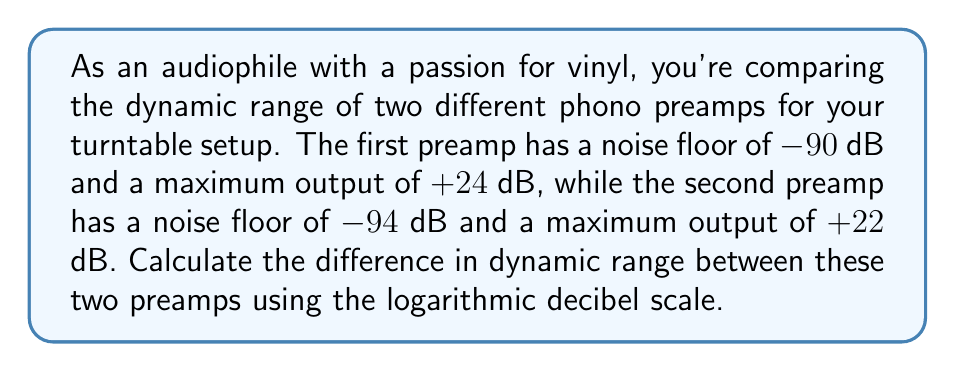Show me your answer to this math problem. To solve this problem, we'll follow these steps:

1. Calculate the dynamic range of each preamp:
   Dynamic range = Maximum output - Noise floor

2. For the first preamp:
   $DR_1 = (+24 \text{ dB}) - (-90 \text{ dB}) = 114 \text{ dB}$

3. For the second preamp:
   $DR_2 = (+22 \text{ dB}) - (-94 \text{ dB}) = 116 \text{ dB}$

4. Calculate the difference in dynamic range:
   $\Delta DR = DR_2 - DR_1 = 116 \text{ dB} - 114 \text{ dB} = 2 \text{ dB}$

The difference in dynamic range between the two preamps is 2 dB, with the second preamp having a slightly larger dynamic range.

It's worth noting that in audio equipment, a larger dynamic range generally allows for better reproduction of both quiet and loud sounds, potentially resulting in a more detailed and nuanced listening experience for vinyl enthusiasts.
Answer: 2 dB 